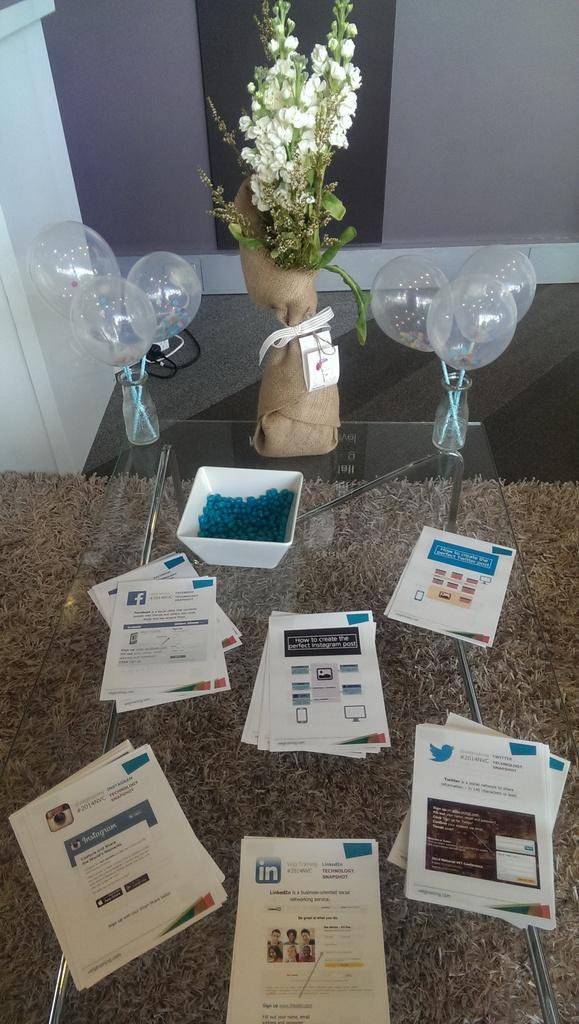Could you give a brief overview of what you see in this image? In this image we can see a table, on the table, we can see some papers, bowl with some objects, balloons and some other objects, we can see a mat and the wall. 